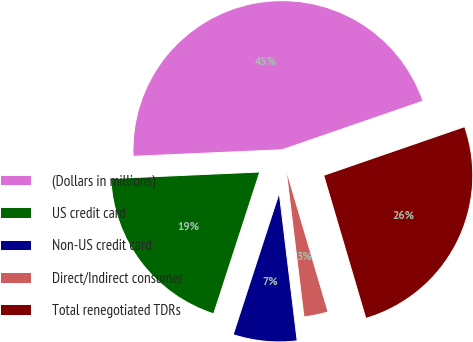<chart> <loc_0><loc_0><loc_500><loc_500><pie_chart><fcel>(Dollars in millions)<fcel>US credit card<fcel>Non-US credit card<fcel>Direct/Indirect consumer<fcel>Total renegotiated TDRs<nl><fcel>45.41%<fcel>19.3%<fcel>6.92%<fcel>2.64%<fcel>25.73%<nl></chart> 